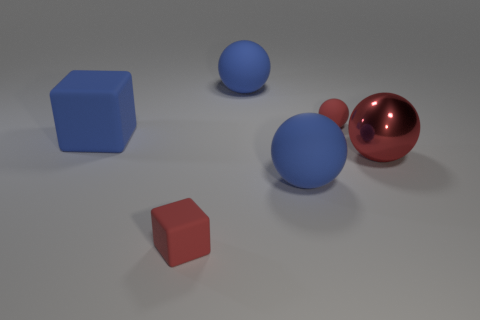Subtract 1 spheres. How many spheres are left? 3 Add 1 red matte spheres. How many objects exist? 7 Subtract all cubes. How many objects are left? 4 Add 6 big blue rubber spheres. How many big blue rubber spheres are left? 8 Add 3 tiny gray blocks. How many tiny gray blocks exist? 3 Subtract 0 cyan spheres. How many objects are left? 6 Subtract all small purple metallic things. Subtract all large red objects. How many objects are left? 5 